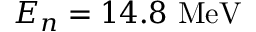Convert formula to latex. <formula><loc_0><loc_0><loc_500><loc_500>E _ { n } = 1 4 . 8 M e V</formula> 